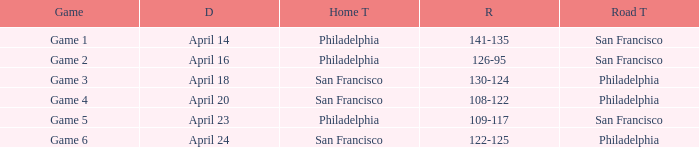On what date was game 2 played? April 16. 